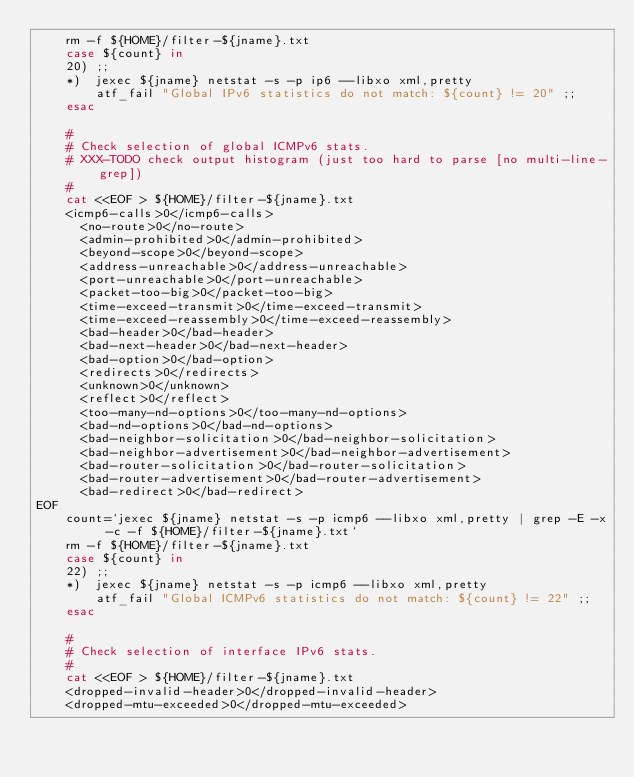Convert code to text. <code><loc_0><loc_0><loc_500><loc_500><_Bash_>	rm -f ${HOME}/filter-${jname}.txt
	case ${count} in
	20)	;;
	*)	jexec ${jname} netstat -s -p ip6 --libxo xml,pretty
		atf_fail "Global IPv6 statistics do not match: ${count} != 20" ;;
	esac

	#
	# Check selection of global ICMPv6 stats.
	# XXX-TODO check output histogram (just too hard to parse [no multi-line-grep])
	#
	cat <<EOF > ${HOME}/filter-${jname}.txt
    <icmp6-calls>0</icmp6-calls>
      <no-route>0</no-route>
      <admin-prohibited>0</admin-prohibited>
      <beyond-scope>0</beyond-scope>
      <address-unreachable>0</address-unreachable>
      <port-unreachable>0</port-unreachable>
      <packet-too-big>0</packet-too-big>
      <time-exceed-transmit>0</time-exceed-transmit>
      <time-exceed-reassembly>0</time-exceed-reassembly>
      <bad-header>0</bad-header>
      <bad-next-header>0</bad-next-header>
      <bad-option>0</bad-option>
      <redirects>0</redirects>
      <unknown>0</unknown>
      <reflect>0</reflect>
      <too-many-nd-options>0</too-many-nd-options>
      <bad-nd-options>0</bad-nd-options>
      <bad-neighbor-solicitation>0</bad-neighbor-solicitation>
      <bad-neighbor-advertisement>0</bad-neighbor-advertisement>
      <bad-router-solicitation>0</bad-router-solicitation>
      <bad-router-advertisement>0</bad-router-advertisement>
      <bad-redirect>0</bad-redirect>
EOF
	count=`jexec ${jname} netstat -s -p icmp6 --libxo xml,pretty | grep -E -x -c -f ${HOME}/filter-${jname}.txt`
	rm -f ${HOME}/filter-${jname}.txt
	case ${count} in
	22)	;;
	*)	jexec ${jname} netstat -s -p icmp6 --libxo xml,pretty
		atf_fail "Global ICMPv6 statistics do not match: ${count} != 22" ;;
	esac

	#
	# Check selection of interface IPv6 stats.
	#
	cat <<EOF > ${HOME}/filter-${jname}.txt
    <dropped-invalid-header>0</dropped-invalid-header>
    <dropped-mtu-exceeded>0</dropped-mtu-exceeded></code> 